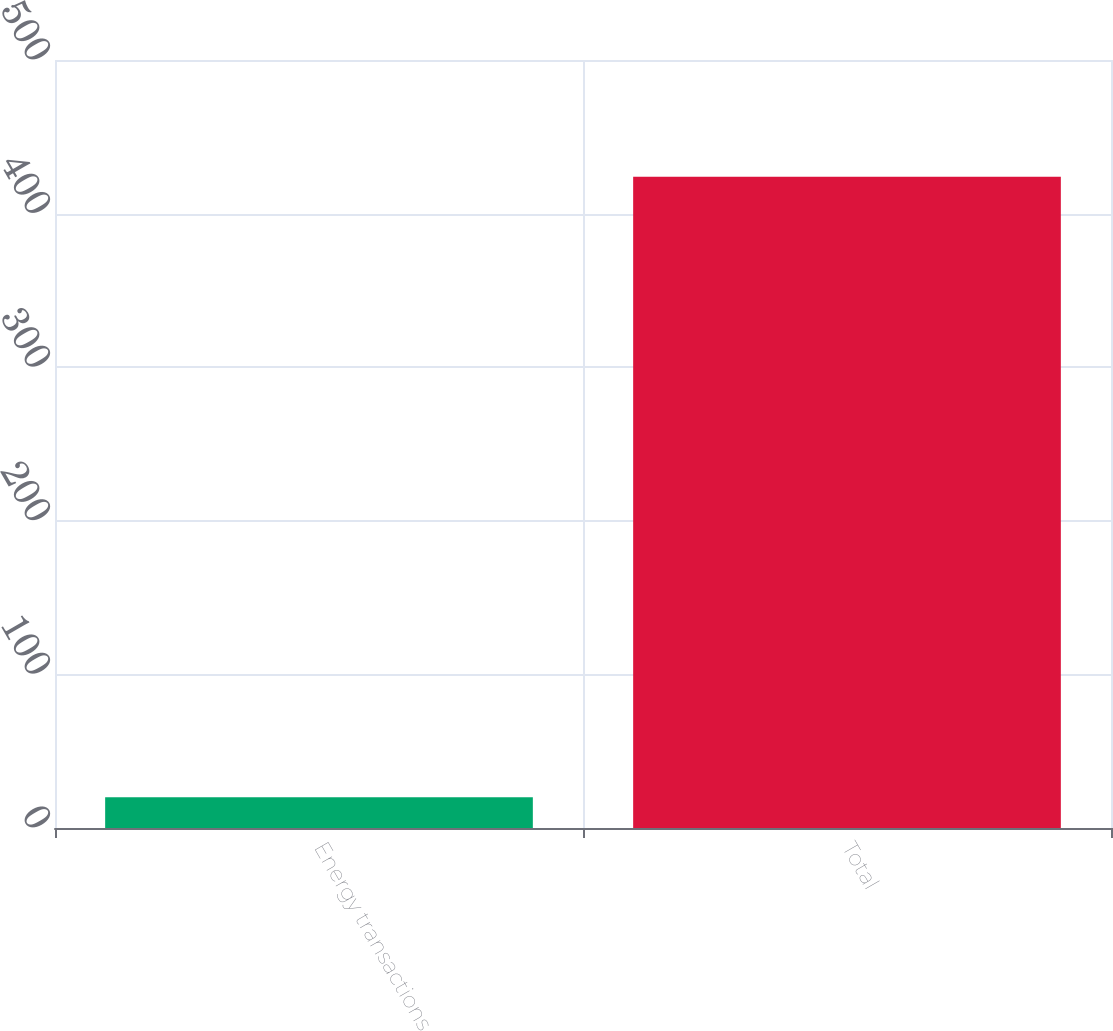Convert chart. <chart><loc_0><loc_0><loc_500><loc_500><bar_chart><fcel>Energy transactions<fcel>Total<nl><fcel>20<fcel>424<nl></chart> 